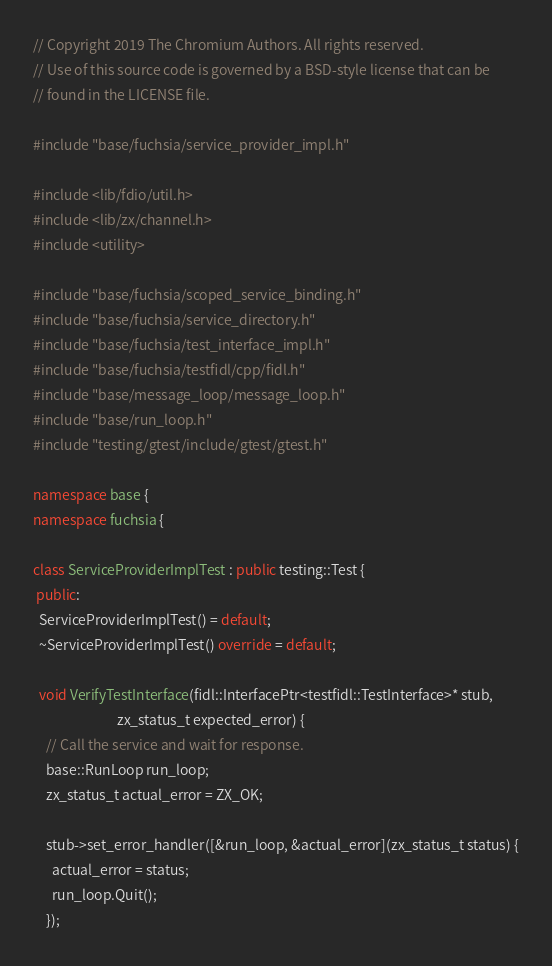Convert code to text. <code><loc_0><loc_0><loc_500><loc_500><_C++_>// Copyright 2019 The Chromium Authors. All rights reserved.
// Use of this source code is governed by a BSD-style license that can be
// found in the LICENSE file.

#include "base/fuchsia/service_provider_impl.h"

#include <lib/fdio/util.h>
#include <lib/zx/channel.h>
#include <utility>

#include "base/fuchsia/scoped_service_binding.h"
#include "base/fuchsia/service_directory.h"
#include "base/fuchsia/test_interface_impl.h"
#include "base/fuchsia/testfidl/cpp/fidl.h"
#include "base/message_loop/message_loop.h"
#include "base/run_loop.h"
#include "testing/gtest/include/gtest/gtest.h"

namespace base {
namespace fuchsia {

class ServiceProviderImplTest : public testing::Test {
 public:
  ServiceProviderImplTest() = default;
  ~ServiceProviderImplTest() override = default;

  void VerifyTestInterface(fidl::InterfacePtr<testfidl::TestInterface>* stub,
                           zx_status_t expected_error) {
    // Call the service and wait for response.
    base::RunLoop run_loop;
    zx_status_t actual_error = ZX_OK;

    stub->set_error_handler([&run_loop, &actual_error](zx_status_t status) {
      actual_error = status;
      run_loop.Quit();
    });
</code> 